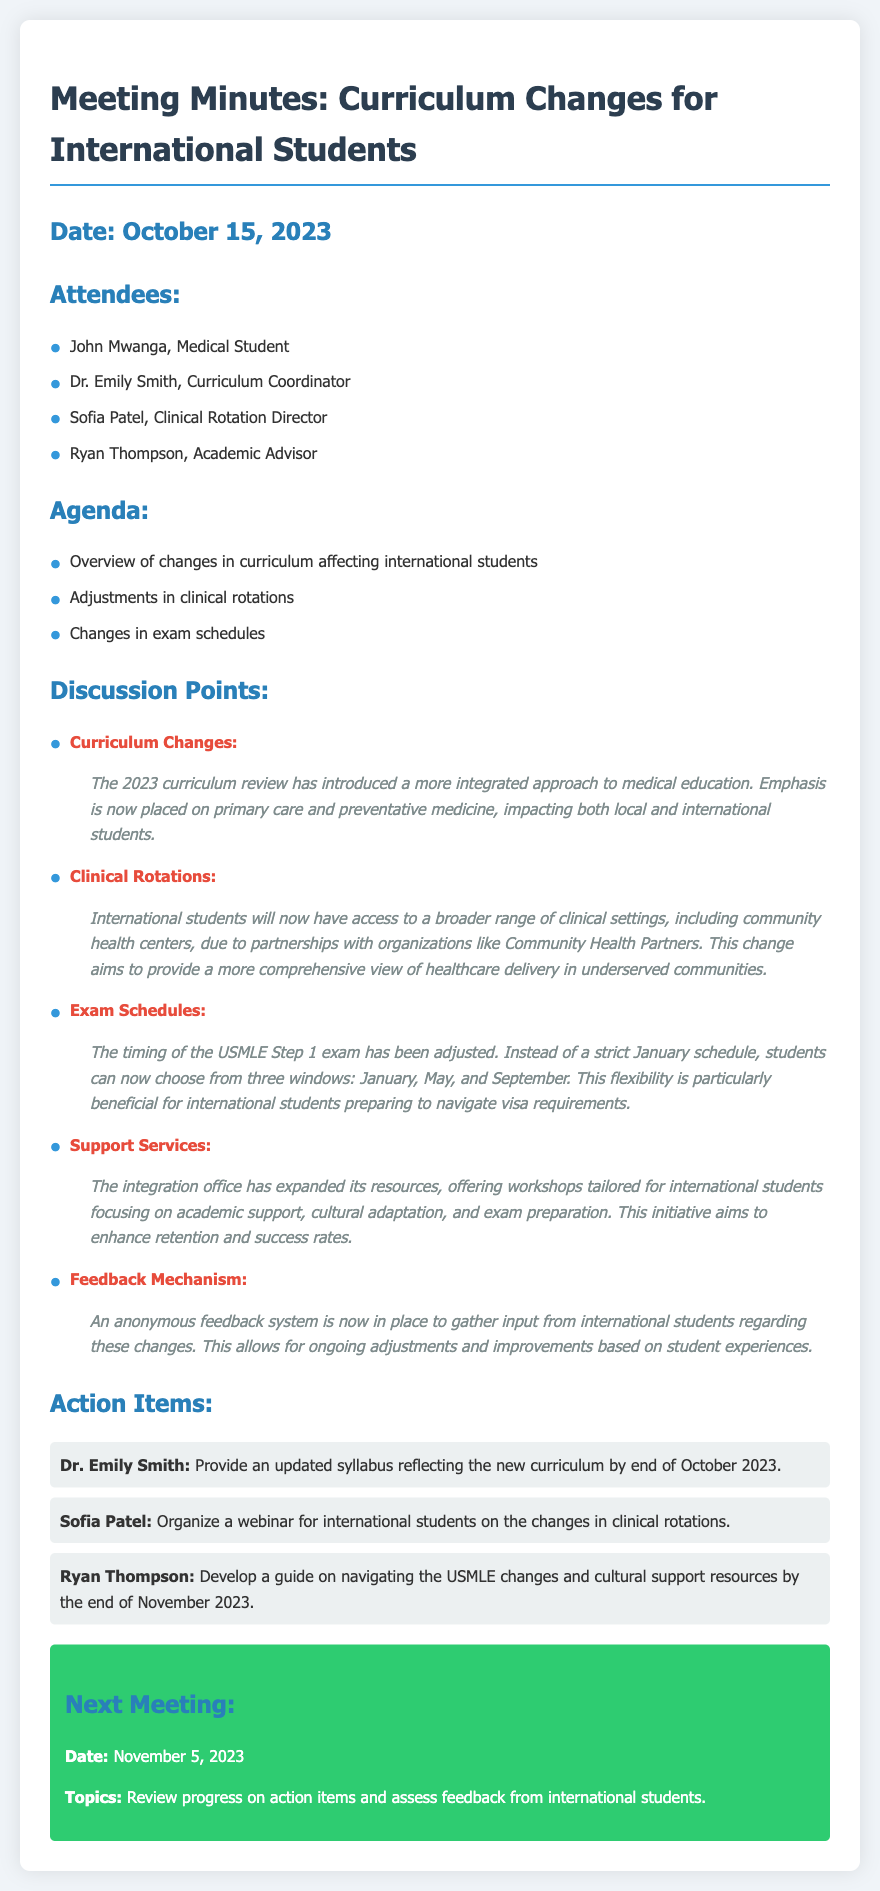What is the date of the meeting? The date of the meeting is stated in the header of the document.
Answer: October 15, 2023 Who is the Clinical Rotation Director? This information is retrieved from the list of attendees at the beginning of the document.
Answer: Sofia Patel What new flexibility is allowed for the USMLE Step 1 exam? This is mentioned under the discussion points about exam schedules.
Answer: Three windows: January, May, and September What is the purpose of the expanded resources offered by the integration office? The purpose is explained in the support services section of the discussion points.
Answer: Enhance retention and success rates Who is responsible for organizing a webinar for international students? This is found in the action items section where roles are assigned.
Answer: Sofia Patel What feedback mechanism has been introduced for international students? This is detailed in the discussion points regarding feedback mechanisms.
Answer: Anonymous feedback system What is the next meeting date? The date for the next meeting is clearly stated in the next meeting section.
Answer: November 5, 2023 What type of approach has been introduced in the curriculum changes? The type of approach is outlined in the curriculum changes section of the discussion points.
Answer: Integrated approach to medical education 